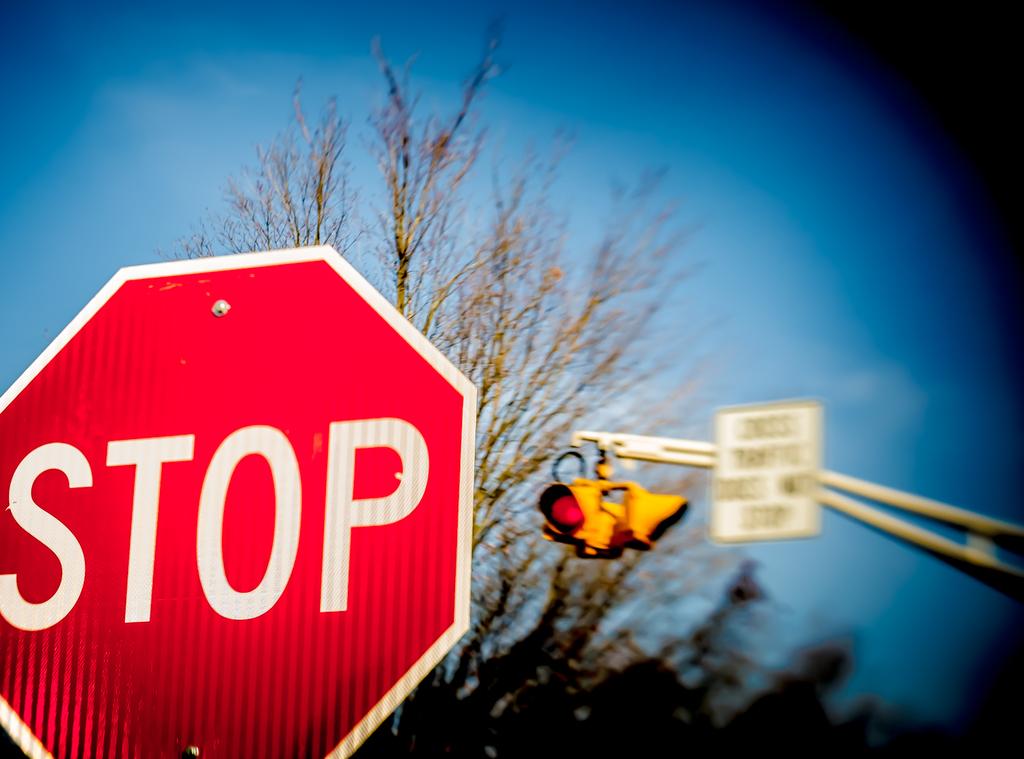What should they do at this road?
Provide a succinct answer. Stop. 